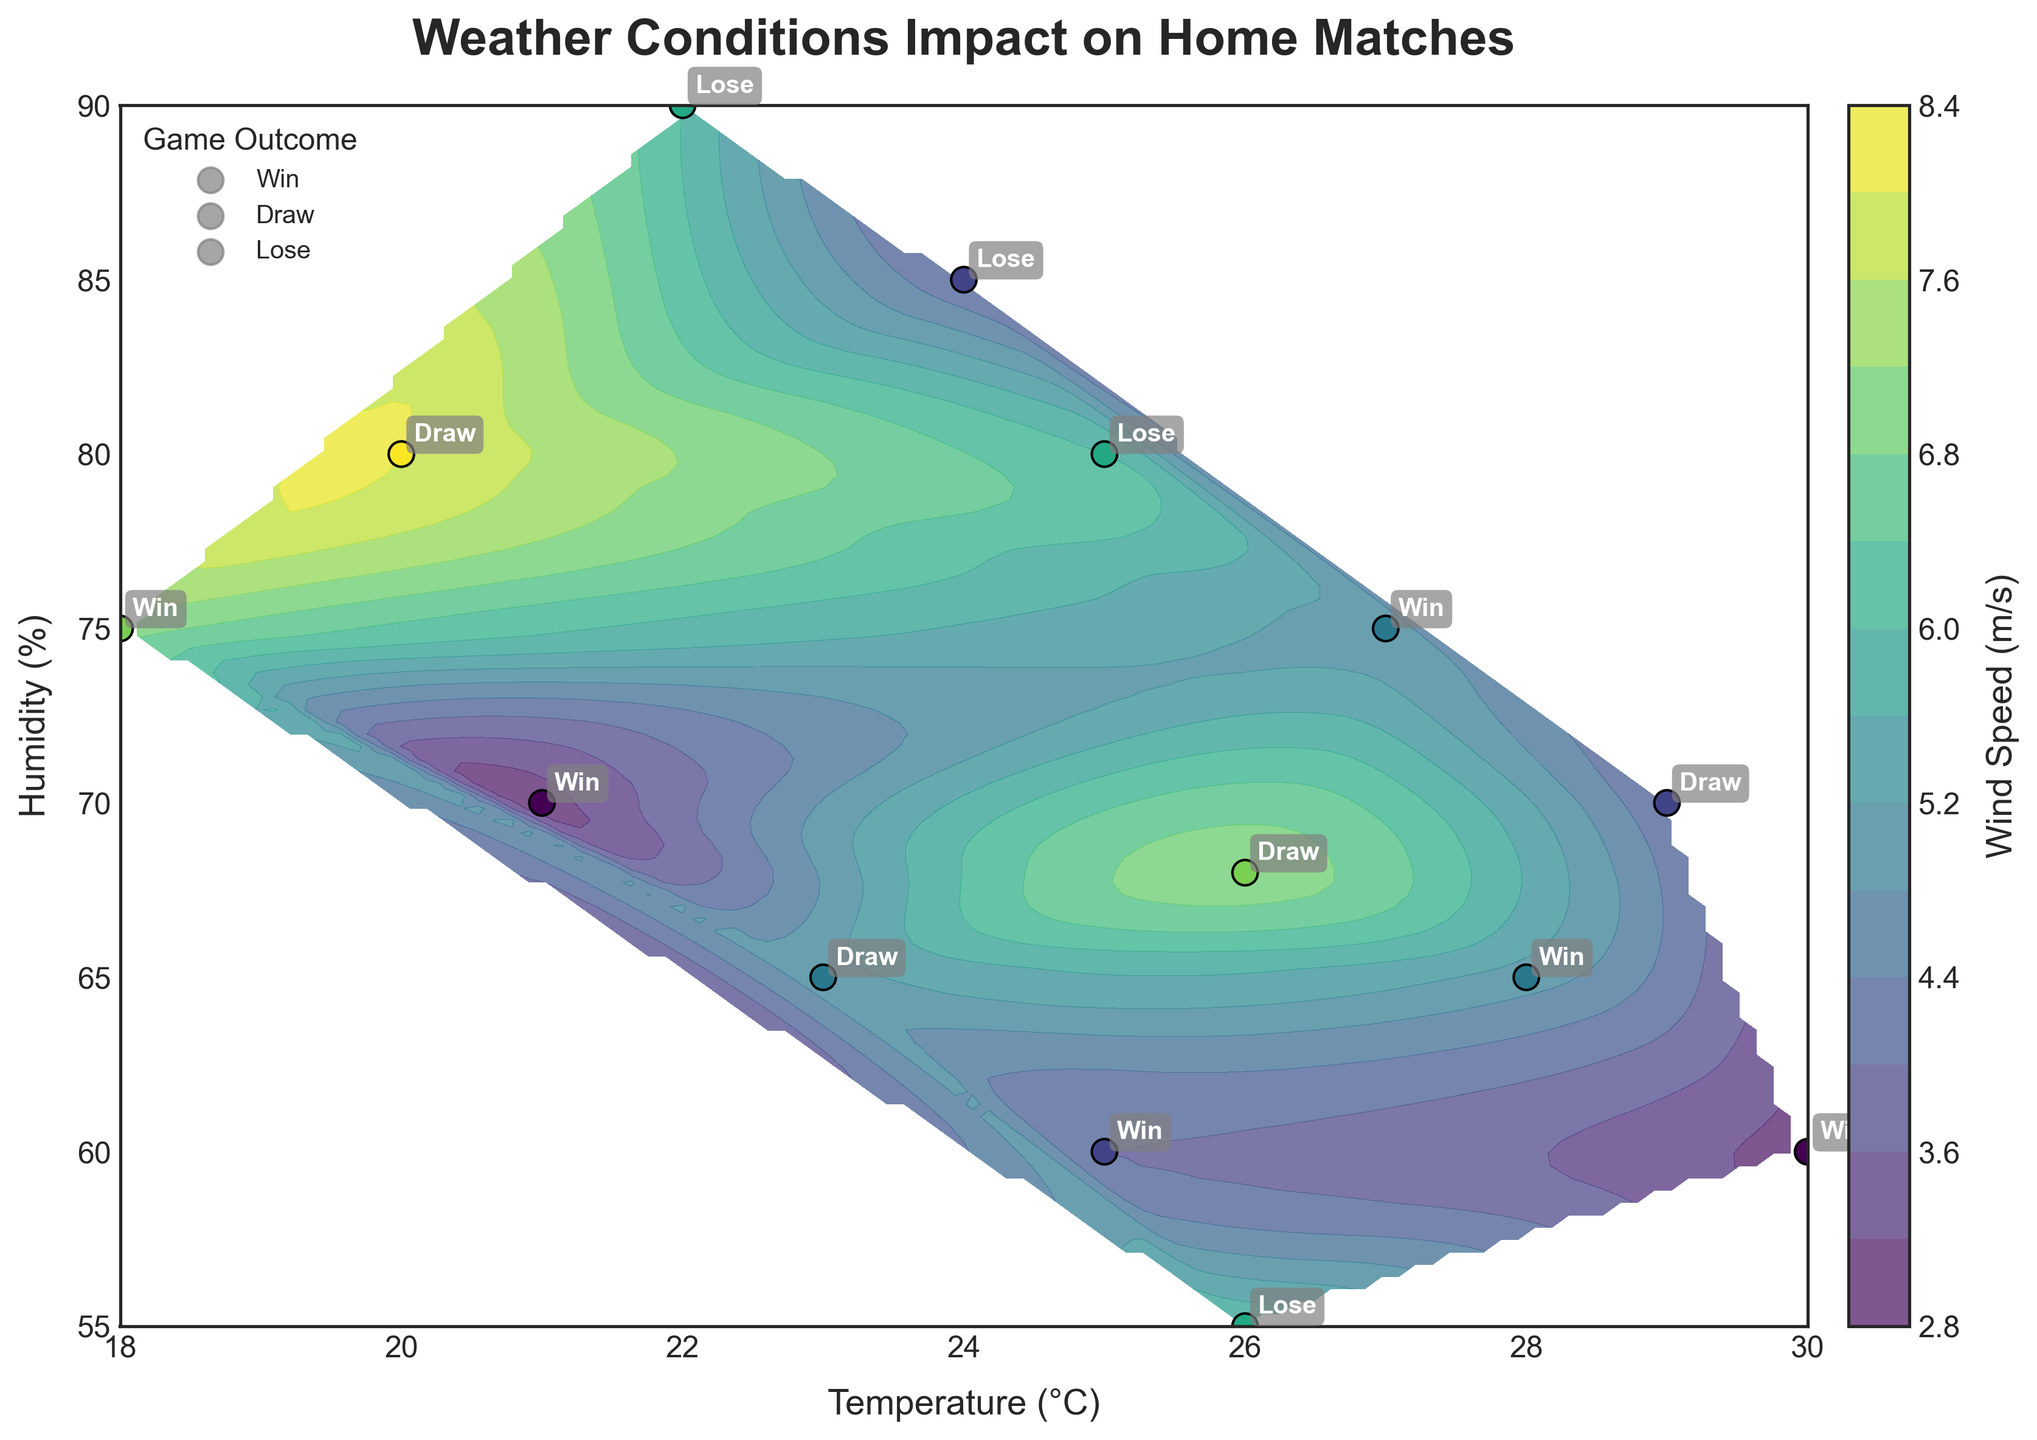How many data points are shown in the plot? Count the number of scatter points on the plot, each representing a match.
Answer: 13 What are the axis labels of the plot? Read the text labels on the x-axis and y-axis of the plot.
Answer: Temperature (°C), Humidity (%) Which temperature and humidity combination had the highest wind speed? Identify the scatter point with the darkest color, check its temperature and humidity values from the axes.
Answer: 20°C, 80% What game outcome appears the most on the plot? Count the annotations for each game outcome. Determine which one is most frequent.
Answer: Win On average, what is the temperature for games that resulted in a draw? Find the points labeled as "Draw", sum their temperatures, and divide by the number of draws. Temperatures are 29, 26, 20, 23. Average calculation: (29+26+20+23)/4 = 24.5
Answer: 24.5°C Is there any correlation between humidity and game outcome? Examine the range of humidity values for each outcome annotation (Win, Draw, Lose) on the plot.
Answer: Wins often occur at lower humidities, Draws and Losses at higher humidities How does wind speed vary with temperature changes in the plot? Observe the gradient and contour levels relative to the x-axis (temperature) variations.
Answer: Wind speed increases with decreasing temperature Which game had the coldest temperature, and what was the outcome? Identify the scatter point with the lowest x-axis value (temperature) and check its annotation.
Answer: 18°C, Win At what combination of weather conditions (temperature, humidity) did the club's last home game occur, and what was the outcome? Identify the last data point based on the sequential date and check its temperature, humidity, and outcome annotation.
Answer: 26°C, 55%, Lose Do higher temperatures generally correspond to wins or losses? Observe the scatter points with higher x-axis values (temperature) and see their outcome annotations.
Answer: Wins generally correspond to higher temperatures 